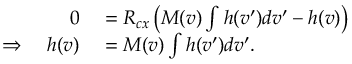<formula> <loc_0><loc_0><loc_500><loc_500>\begin{array} { r l } { 0 } & = R _ { c x } \left ( M ( v ) \int h ( v ^ { \prime } ) d v ^ { \prime } - h ( v ) \right ) } \\ { \Rightarrow \quad h ( v ) } & = M ( v ) \int h ( v ^ { \prime } ) d v ^ { \prime } . } \end{array}</formula> 